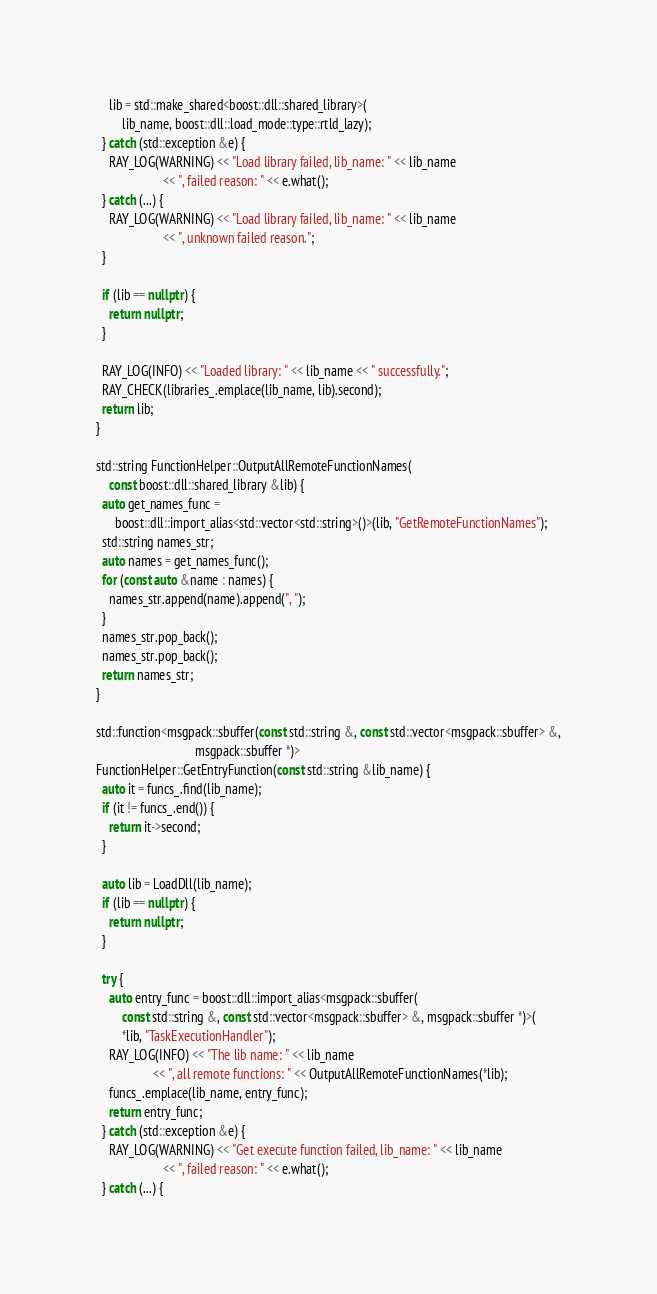Convert code to text. <code><loc_0><loc_0><loc_500><loc_500><_C++_>    lib = std::make_shared<boost::dll::shared_library>(
        lib_name, boost::dll::load_mode::type::rtld_lazy);
  } catch (std::exception &e) {
    RAY_LOG(WARNING) << "Load library failed, lib_name: " << lib_name
                     << ", failed reason: " << e.what();
  } catch (...) {
    RAY_LOG(WARNING) << "Load library failed, lib_name: " << lib_name
                     << ", unknown failed reason.";
  }

  if (lib == nullptr) {
    return nullptr;
  }

  RAY_LOG(INFO) << "Loaded library: " << lib_name << " successfully.";
  RAY_CHECK(libraries_.emplace(lib_name, lib).second);
  return lib;
}

std::string FunctionHelper::OutputAllRemoteFunctionNames(
    const boost::dll::shared_library &lib) {
  auto get_names_func =
      boost::dll::import_alias<std::vector<std::string>()>(lib, "GetRemoteFunctionNames");
  std::string names_str;
  auto names = get_names_func();
  for (const auto &name : names) {
    names_str.append(name).append(", ");
  }
  names_str.pop_back();
  names_str.pop_back();
  return names_str;
}

std::function<msgpack::sbuffer(const std::string &, const std::vector<msgpack::sbuffer> &,
                               msgpack::sbuffer *)>
FunctionHelper::GetEntryFunction(const std::string &lib_name) {
  auto it = funcs_.find(lib_name);
  if (it != funcs_.end()) {
    return it->second;
  }

  auto lib = LoadDll(lib_name);
  if (lib == nullptr) {
    return nullptr;
  }

  try {
    auto entry_func = boost::dll::import_alias<msgpack::sbuffer(
        const std::string &, const std::vector<msgpack::sbuffer> &, msgpack::sbuffer *)>(
        *lib, "TaskExecutionHandler");
    RAY_LOG(INFO) << "The lib name: " << lib_name
                  << ", all remote functions: " << OutputAllRemoteFunctionNames(*lib);
    funcs_.emplace(lib_name, entry_func);
    return entry_func;
  } catch (std::exception &e) {
    RAY_LOG(WARNING) << "Get execute function failed, lib_name: " << lib_name
                     << ", failed reason: " << e.what();
  } catch (...) {</code> 